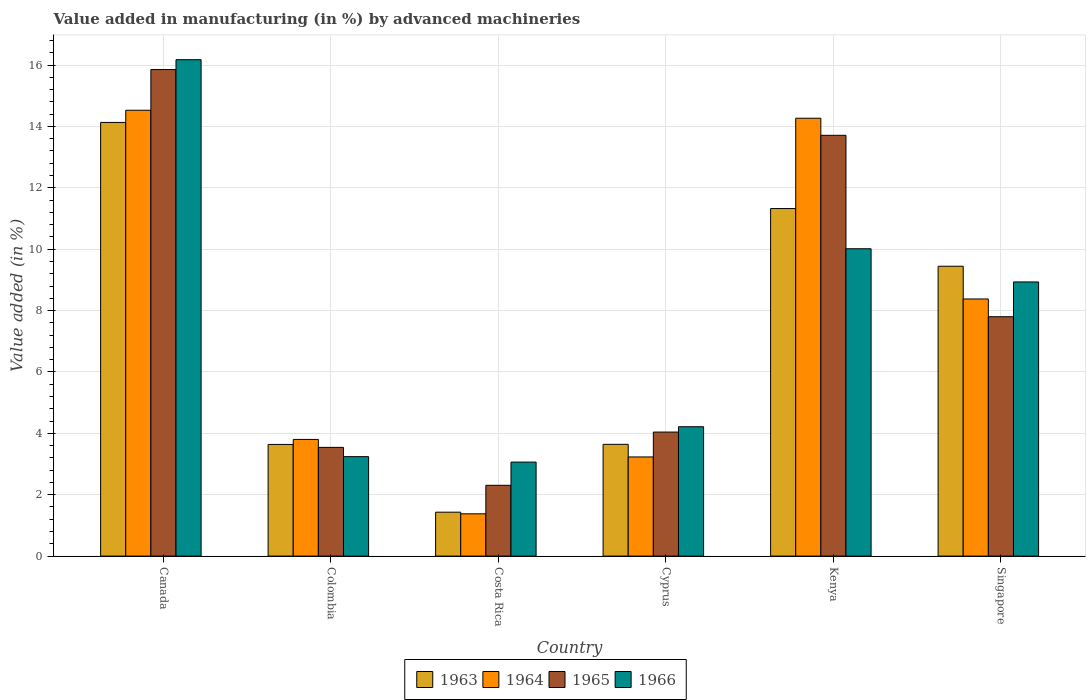What is the label of the 6th group of bars from the left?
Your answer should be very brief. Singapore. What is the percentage of value added in manufacturing by advanced machineries in 1964 in Colombia?
Your response must be concise. 3.8. Across all countries, what is the maximum percentage of value added in manufacturing by advanced machineries in 1964?
Provide a succinct answer. 14.53. Across all countries, what is the minimum percentage of value added in manufacturing by advanced machineries in 1963?
Your answer should be very brief. 1.43. In which country was the percentage of value added in manufacturing by advanced machineries in 1963 maximum?
Your answer should be very brief. Canada. What is the total percentage of value added in manufacturing by advanced machineries in 1966 in the graph?
Provide a succinct answer. 45.64. What is the difference between the percentage of value added in manufacturing by advanced machineries in 1966 in Canada and that in Singapore?
Offer a very short reply. 7.24. What is the difference between the percentage of value added in manufacturing by advanced machineries in 1965 in Canada and the percentage of value added in manufacturing by advanced machineries in 1964 in Colombia?
Provide a short and direct response. 12.05. What is the average percentage of value added in manufacturing by advanced machineries in 1963 per country?
Keep it short and to the point. 7.27. What is the difference between the percentage of value added in manufacturing by advanced machineries of/in 1964 and percentage of value added in manufacturing by advanced machineries of/in 1966 in Colombia?
Provide a succinct answer. 0.56. In how many countries, is the percentage of value added in manufacturing by advanced machineries in 1963 greater than 1.2000000000000002 %?
Give a very brief answer. 6. What is the ratio of the percentage of value added in manufacturing by advanced machineries in 1966 in Colombia to that in Singapore?
Offer a very short reply. 0.36. Is the difference between the percentage of value added in manufacturing by advanced machineries in 1964 in Cyprus and Kenya greater than the difference between the percentage of value added in manufacturing by advanced machineries in 1966 in Cyprus and Kenya?
Your response must be concise. No. What is the difference between the highest and the second highest percentage of value added in manufacturing by advanced machineries in 1964?
Offer a terse response. -6.15. What is the difference between the highest and the lowest percentage of value added in manufacturing by advanced machineries in 1966?
Offer a terse response. 13.11. In how many countries, is the percentage of value added in manufacturing by advanced machineries in 1965 greater than the average percentage of value added in manufacturing by advanced machineries in 1965 taken over all countries?
Make the answer very short. 2. What does the 2nd bar from the left in Canada represents?
Ensure brevity in your answer.  1964. What does the 4th bar from the right in Canada represents?
Offer a terse response. 1963. Is it the case that in every country, the sum of the percentage of value added in manufacturing by advanced machineries in 1963 and percentage of value added in manufacturing by advanced machineries in 1964 is greater than the percentage of value added in manufacturing by advanced machineries in 1966?
Your response must be concise. No. How many bars are there?
Keep it short and to the point. 24. How many countries are there in the graph?
Make the answer very short. 6. What is the difference between two consecutive major ticks on the Y-axis?
Your response must be concise. 2. Are the values on the major ticks of Y-axis written in scientific E-notation?
Your answer should be compact. No. Does the graph contain grids?
Provide a succinct answer. Yes. Where does the legend appear in the graph?
Provide a succinct answer. Bottom center. How many legend labels are there?
Keep it short and to the point. 4. What is the title of the graph?
Ensure brevity in your answer.  Value added in manufacturing (in %) by advanced machineries. What is the label or title of the Y-axis?
Keep it short and to the point. Value added (in %). What is the Value added (in %) in 1963 in Canada?
Your answer should be compact. 14.13. What is the Value added (in %) of 1964 in Canada?
Offer a terse response. 14.53. What is the Value added (in %) of 1965 in Canada?
Offer a very short reply. 15.85. What is the Value added (in %) of 1966 in Canada?
Your answer should be compact. 16.17. What is the Value added (in %) of 1963 in Colombia?
Your response must be concise. 3.64. What is the Value added (in %) in 1964 in Colombia?
Provide a short and direct response. 3.8. What is the Value added (in %) in 1965 in Colombia?
Your answer should be very brief. 3.54. What is the Value added (in %) of 1966 in Colombia?
Your response must be concise. 3.24. What is the Value added (in %) in 1963 in Costa Rica?
Give a very brief answer. 1.43. What is the Value added (in %) in 1964 in Costa Rica?
Give a very brief answer. 1.38. What is the Value added (in %) in 1965 in Costa Rica?
Offer a very short reply. 2.31. What is the Value added (in %) of 1966 in Costa Rica?
Your response must be concise. 3.06. What is the Value added (in %) of 1963 in Cyprus?
Offer a terse response. 3.64. What is the Value added (in %) of 1964 in Cyprus?
Provide a short and direct response. 3.23. What is the Value added (in %) of 1965 in Cyprus?
Offer a terse response. 4.04. What is the Value added (in %) in 1966 in Cyprus?
Provide a short and direct response. 4.22. What is the Value added (in %) of 1963 in Kenya?
Keep it short and to the point. 11.32. What is the Value added (in %) of 1964 in Kenya?
Keep it short and to the point. 14.27. What is the Value added (in %) of 1965 in Kenya?
Offer a very short reply. 13.71. What is the Value added (in %) in 1966 in Kenya?
Provide a succinct answer. 10.01. What is the Value added (in %) of 1963 in Singapore?
Make the answer very short. 9.44. What is the Value added (in %) of 1964 in Singapore?
Ensure brevity in your answer.  8.38. What is the Value added (in %) of 1965 in Singapore?
Provide a succinct answer. 7.8. What is the Value added (in %) in 1966 in Singapore?
Provide a short and direct response. 8.93. Across all countries, what is the maximum Value added (in %) of 1963?
Your response must be concise. 14.13. Across all countries, what is the maximum Value added (in %) of 1964?
Ensure brevity in your answer.  14.53. Across all countries, what is the maximum Value added (in %) in 1965?
Offer a very short reply. 15.85. Across all countries, what is the maximum Value added (in %) of 1966?
Your answer should be compact. 16.17. Across all countries, what is the minimum Value added (in %) in 1963?
Offer a terse response. 1.43. Across all countries, what is the minimum Value added (in %) in 1964?
Your answer should be very brief. 1.38. Across all countries, what is the minimum Value added (in %) in 1965?
Your answer should be very brief. 2.31. Across all countries, what is the minimum Value added (in %) in 1966?
Offer a terse response. 3.06. What is the total Value added (in %) of 1963 in the graph?
Ensure brevity in your answer.  43.61. What is the total Value added (in %) of 1964 in the graph?
Keep it short and to the point. 45.58. What is the total Value added (in %) of 1965 in the graph?
Provide a short and direct response. 47.25. What is the total Value added (in %) in 1966 in the graph?
Your answer should be compact. 45.64. What is the difference between the Value added (in %) of 1963 in Canada and that in Colombia?
Your response must be concise. 10.49. What is the difference between the Value added (in %) in 1964 in Canada and that in Colombia?
Your response must be concise. 10.72. What is the difference between the Value added (in %) in 1965 in Canada and that in Colombia?
Keep it short and to the point. 12.31. What is the difference between the Value added (in %) of 1966 in Canada and that in Colombia?
Provide a short and direct response. 12.93. What is the difference between the Value added (in %) in 1963 in Canada and that in Costa Rica?
Offer a very short reply. 12.7. What is the difference between the Value added (in %) of 1964 in Canada and that in Costa Rica?
Make the answer very short. 13.15. What is the difference between the Value added (in %) in 1965 in Canada and that in Costa Rica?
Ensure brevity in your answer.  13.55. What is the difference between the Value added (in %) of 1966 in Canada and that in Costa Rica?
Your response must be concise. 13.11. What is the difference between the Value added (in %) of 1963 in Canada and that in Cyprus?
Ensure brevity in your answer.  10.49. What is the difference between the Value added (in %) in 1964 in Canada and that in Cyprus?
Offer a very short reply. 11.3. What is the difference between the Value added (in %) in 1965 in Canada and that in Cyprus?
Your response must be concise. 11.81. What is the difference between the Value added (in %) of 1966 in Canada and that in Cyprus?
Offer a very short reply. 11.96. What is the difference between the Value added (in %) of 1963 in Canada and that in Kenya?
Make the answer very short. 2.81. What is the difference between the Value added (in %) of 1964 in Canada and that in Kenya?
Offer a very short reply. 0.26. What is the difference between the Value added (in %) in 1965 in Canada and that in Kenya?
Your response must be concise. 2.14. What is the difference between the Value added (in %) of 1966 in Canada and that in Kenya?
Provide a succinct answer. 6.16. What is the difference between the Value added (in %) of 1963 in Canada and that in Singapore?
Make the answer very short. 4.69. What is the difference between the Value added (in %) of 1964 in Canada and that in Singapore?
Offer a terse response. 6.15. What is the difference between the Value added (in %) in 1965 in Canada and that in Singapore?
Make the answer very short. 8.05. What is the difference between the Value added (in %) of 1966 in Canada and that in Singapore?
Offer a terse response. 7.24. What is the difference between the Value added (in %) of 1963 in Colombia and that in Costa Rica?
Your answer should be compact. 2.21. What is the difference between the Value added (in %) of 1964 in Colombia and that in Costa Rica?
Provide a succinct answer. 2.42. What is the difference between the Value added (in %) in 1965 in Colombia and that in Costa Rica?
Keep it short and to the point. 1.24. What is the difference between the Value added (in %) in 1966 in Colombia and that in Costa Rica?
Make the answer very short. 0.18. What is the difference between the Value added (in %) of 1963 in Colombia and that in Cyprus?
Make the answer very short. -0. What is the difference between the Value added (in %) in 1964 in Colombia and that in Cyprus?
Provide a succinct answer. 0.57. What is the difference between the Value added (in %) of 1965 in Colombia and that in Cyprus?
Offer a terse response. -0.5. What is the difference between the Value added (in %) of 1966 in Colombia and that in Cyprus?
Ensure brevity in your answer.  -0.97. What is the difference between the Value added (in %) in 1963 in Colombia and that in Kenya?
Give a very brief answer. -7.69. What is the difference between the Value added (in %) of 1964 in Colombia and that in Kenya?
Ensure brevity in your answer.  -10.47. What is the difference between the Value added (in %) in 1965 in Colombia and that in Kenya?
Provide a short and direct response. -10.17. What is the difference between the Value added (in %) in 1966 in Colombia and that in Kenya?
Your answer should be very brief. -6.77. What is the difference between the Value added (in %) in 1963 in Colombia and that in Singapore?
Provide a short and direct response. -5.81. What is the difference between the Value added (in %) in 1964 in Colombia and that in Singapore?
Your answer should be very brief. -4.58. What is the difference between the Value added (in %) of 1965 in Colombia and that in Singapore?
Ensure brevity in your answer.  -4.26. What is the difference between the Value added (in %) in 1966 in Colombia and that in Singapore?
Your answer should be compact. -5.69. What is the difference between the Value added (in %) in 1963 in Costa Rica and that in Cyprus?
Your answer should be compact. -2.21. What is the difference between the Value added (in %) in 1964 in Costa Rica and that in Cyprus?
Offer a very short reply. -1.85. What is the difference between the Value added (in %) in 1965 in Costa Rica and that in Cyprus?
Provide a succinct answer. -1.73. What is the difference between the Value added (in %) of 1966 in Costa Rica and that in Cyprus?
Make the answer very short. -1.15. What is the difference between the Value added (in %) in 1963 in Costa Rica and that in Kenya?
Ensure brevity in your answer.  -9.89. What is the difference between the Value added (in %) in 1964 in Costa Rica and that in Kenya?
Your response must be concise. -12.89. What is the difference between the Value added (in %) in 1965 in Costa Rica and that in Kenya?
Your response must be concise. -11.4. What is the difference between the Value added (in %) of 1966 in Costa Rica and that in Kenya?
Offer a very short reply. -6.95. What is the difference between the Value added (in %) of 1963 in Costa Rica and that in Singapore?
Offer a terse response. -8.01. What is the difference between the Value added (in %) of 1964 in Costa Rica and that in Singapore?
Your answer should be compact. -7. What is the difference between the Value added (in %) of 1965 in Costa Rica and that in Singapore?
Your answer should be very brief. -5.49. What is the difference between the Value added (in %) of 1966 in Costa Rica and that in Singapore?
Make the answer very short. -5.87. What is the difference between the Value added (in %) of 1963 in Cyprus and that in Kenya?
Provide a short and direct response. -7.68. What is the difference between the Value added (in %) in 1964 in Cyprus and that in Kenya?
Provide a succinct answer. -11.04. What is the difference between the Value added (in %) of 1965 in Cyprus and that in Kenya?
Provide a short and direct response. -9.67. What is the difference between the Value added (in %) in 1966 in Cyprus and that in Kenya?
Your answer should be very brief. -5.8. What is the difference between the Value added (in %) in 1963 in Cyprus and that in Singapore?
Provide a succinct answer. -5.8. What is the difference between the Value added (in %) in 1964 in Cyprus and that in Singapore?
Offer a very short reply. -5.15. What is the difference between the Value added (in %) of 1965 in Cyprus and that in Singapore?
Make the answer very short. -3.76. What is the difference between the Value added (in %) of 1966 in Cyprus and that in Singapore?
Ensure brevity in your answer.  -4.72. What is the difference between the Value added (in %) of 1963 in Kenya and that in Singapore?
Keep it short and to the point. 1.88. What is the difference between the Value added (in %) in 1964 in Kenya and that in Singapore?
Give a very brief answer. 5.89. What is the difference between the Value added (in %) in 1965 in Kenya and that in Singapore?
Your response must be concise. 5.91. What is the difference between the Value added (in %) in 1966 in Kenya and that in Singapore?
Your answer should be very brief. 1.08. What is the difference between the Value added (in %) in 1963 in Canada and the Value added (in %) in 1964 in Colombia?
Your answer should be very brief. 10.33. What is the difference between the Value added (in %) of 1963 in Canada and the Value added (in %) of 1965 in Colombia?
Ensure brevity in your answer.  10.59. What is the difference between the Value added (in %) in 1963 in Canada and the Value added (in %) in 1966 in Colombia?
Your response must be concise. 10.89. What is the difference between the Value added (in %) of 1964 in Canada and the Value added (in %) of 1965 in Colombia?
Offer a terse response. 10.98. What is the difference between the Value added (in %) in 1964 in Canada and the Value added (in %) in 1966 in Colombia?
Offer a very short reply. 11.29. What is the difference between the Value added (in %) of 1965 in Canada and the Value added (in %) of 1966 in Colombia?
Offer a very short reply. 12.61. What is the difference between the Value added (in %) in 1963 in Canada and the Value added (in %) in 1964 in Costa Rica?
Your answer should be very brief. 12.75. What is the difference between the Value added (in %) in 1963 in Canada and the Value added (in %) in 1965 in Costa Rica?
Keep it short and to the point. 11.82. What is the difference between the Value added (in %) in 1963 in Canada and the Value added (in %) in 1966 in Costa Rica?
Give a very brief answer. 11.07. What is the difference between the Value added (in %) in 1964 in Canada and the Value added (in %) in 1965 in Costa Rica?
Provide a short and direct response. 12.22. What is the difference between the Value added (in %) of 1964 in Canada and the Value added (in %) of 1966 in Costa Rica?
Make the answer very short. 11.46. What is the difference between the Value added (in %) in 1965 in Canada and the Value added (in %) in 1966 in Costa Rica?
Keep it short and to the point. 12.79. What is the difference between the Value added (in %) of 1963 in Canada and the Value added (in %) of 1964 in Cyprus?
Your answer should be very brief. 10.9. What is the difference between the Value added (in %) of 1963 in Canada and the Value added (in %) of 1965 in Cyprus?
Provide a short and direct response. 10.09. What is the difference between the Value added (in %) of 1963 in Canada and the Value added (in %) of 1966 in Cyprus?
Provide a short and direct response. 9.92. What is the difference between the Value added (in %) in 1964 in Canada and the Value added (in %) in 1965 in Cyprus?
Your answer should be very brief. 10.49. What is the difference between the Value added (in %) of 1964 in Canada and the Value added (in %) of 1966 in Cyprus?
Keep it short and to the point. 10.31. What is the difference between the Value added (in %) of 1965 in Canada and the Value added (in %) of 1966 in Cyprus?
Keep it short and to the point. 11.64. What is the difference between the Value added (in %) of 1963 in Canada and the Value added (in %) of 1964 in Kenya?
Provide a succinct answer. -0.14. What is the difference between the Value added (in %) of 1963 in Canada and the Value added (in %) of 1965 in Kenya?
Ensure brevity in your answer.  0.42. What is the difference between the Value added (in %) in 1963 in Canada and the Value added (in %) in 1966 in Kenya?
Offer a very short reply. 4.12. What is the difference between the Value added (in %) of 1964 in Canada and the Value added (in %) of 1965 in Kenya?
Ensure brevity in your answer.  0.82. What is the difference between the Value added (in %) of 1964 in Canada and the Value added (in %) of 1966 in Kenya?
Offer a terse response. 4.51. What is the difference between the Value added (in %) of 1965 in Canada and the Value added (in %) of 1966 in Kenya?
Offer a very short reply. 5.84. What is the difference between the Value added (in %) of 1963 in Canada and the Value added (in %) of 1964 in Singapore?
Make the answer very short. 5.75. What is the difference between the Value added (in %) of 1963 in Canada and the Value added (in %) of 1965 in Singapore?
Make the answer very short. 6.33. What is the difference between the Value added (in %) of 1963 in Canada and the Value added (in %) of 1966 in Singapore?
Provide a succinct answer. 5.2. What is the difference between the Value added (in %) of 1964 in Canada and the Value added (in %) of 1965 in Singapore?
Give a very brief answer. 6.73. What is the difference between the Value added (in %) of 1964 in Canada and the Value added (in %) of 1966 in Singapore?
Your answer should be very brief. 5.59. What is the difference between the Value added (in %) of 1965 in Canada and the Value added (in %) of 1966 in Singapore?
Offer a very short reply. 6.92. What is the difference between the Value added (in %) in 1963 in Colombia and the Value added (in %) in 1964 in Costa Rica?
Your answer should be very brief. 2.26. What is the difference between the Value added (in %) in 1963 in Colombia and the Value added (in %) in 1965 in Costa Rica?
Make the answer very short. 1.33. What is the difference between the Value added (in %) in 1963 in Colombia and the Value added (in %) in 1966 in Costa Rica?
Your response must be concise. 0.57. What is the difference between the Value added (in %) of 1964 in Colombia and the Value added (in %) of 1965 in Costa Rica?
Provide a succinct answer. 1.49. What is the difference between the Value added (in %) of 1964 in Colombia and the Value added (in %) of 1966 in Costa Rica?
Provide a succinct answer. 0.74. What is the difference between the Value added (in %) of 1965 in Colombia and the Value added (in %) of 1966 in Costa Rica?
Ensure brevity in your answer.  0.48. What is the difference between the Value added (in %) of 1963 in Colombia and the Value added (in %) of 1964 in Cyprus?
Your response must be concise. 0.41. What is the difference between the Value added (in %) in 1963 in Colombia and the Value added (in %) in 1965 in Cyprus?
Your answer should be compact. -0.4. What is the difference between the Value added (in %) in 1963 in Colombia and the Value added (in %) in 1966 in Cyprus?
Offer a terse response. -0.58. What is the difference between the Value added (in %) of 1964 in Colombia and the Value added (in %) of 1965 in Cyprus?
Make the answer very short. -0.24. What is the difference between the Value added (in %) of 1964 in Colombia and the Value added (in %) of 1966 in Cyprus?
Offer a very short reply. -0.41. What is the difference between the Value added (in %) of 1965 in Colombia and the Value added (in %) of 1966 in Cyprus?
Ensure brevity in your answer.  -0.67. What is the difference between the Value added (in %) in 1963 in Colombia and the Value added (in %) in 1964 in Kenya?
Your response must be concise. -10.63. What is the difference between the Value added (in %) of 1963 in Colombia and the Value added (in %) of 1965 in Kenya?
Provide a succinct answer. -10.07. What is the difference between the Value added (in %) in 1963 in Colombia and the Value added (in %) in 1966 in Kenya?
Your answer should be compact. -6.38. What is the difference between the Value added (in %) of 1964 in Colombia and the Value added (in %) of 1965 in Kenya?
Your answer should be compact. -9.91. What is the difference between the Value added (in %) in 1964 in Colombia and the Value added (in %) in 1966 in Kenya?
Ensure brevity in your answer.  -6.21. What is the difference between the Value added (in %) in 1965 in Colombia and the Value added (in %) in 1966 in Kenya?
Make the answer very short. -6.47. What is the difference between the Value added (in %) of 1963 in Colombia and the Value added (in %) of 1964 in Singapore?
Give a very brief answer. -4.74. What is the difference between the Value added (in %) in 1963 in Colombia and the Value added (in %) in 1965 in Singapore?
Give a very brief answer. -4.16. What is the difference between the Value added (in %) in 1963 in Colombia and the Value added (in %) in 1966 in Singapore?
Offer a very short reply. -5.29. What is the difference between the Value added (in %) in 1964 in Colombia and the Value added (in %) in 1965 in Singapore?
Provide a succinct answer. -4. What is the difference between the Value added (in %) of 1964 in Colombia and the Value added (in %) of 1966 in Singapore?
Provide a succinct answer. -5.13. What is the difference between the Value added (in %) in 1965 in Colombia and the Value added (in %) in 1966 in Singapore?
Your response must be concise. -5.39. What is the difference between the Value added (in %) of 1963 in Costa Rica and the Value added (in %) of 1964 in Cyprus?
Give a very brief answer. -1.8. What is the difference between the Value added (in %) in 1963 in Costa Rica and the Value added (in %) in 1965 in Cyprus?
Keep it short and to the point. -2.61. What is the difference between the Value added (in %) in 1963 in Costa Rica and the Value added (in %) in 1966 in Cyprus?
Your response must be concise. -2.78. What is the difference between the Value added (in %) of 1964 in Costa Rica and the Value added (in %) of 1965 in Cyprus?
Provide a short and direct response. -2.66. What is the difference between the Value added (in %) of 1964 in Costa Rica and the Value added (in %) of 1966 in Cyprus?
Offer a very short reply. -2.84. What is the difference between the Value added (in %) in 1965 in Costa Rica and the Value added (in %) in 1966 in Cyprus?
Make the answer very short. -1.91. What is the difference between the Value added (in %) of 1963 in Costa Rica and the Value added (in %) of 1964 in Kenya?
Your answer should be very brief. -12.84. What is the difference between the Value added (in %) in 1963 in Costa Rica and the Value added (in %) in 1965 in Kenya?
Your answer should be very brief. -12.28. What is the difference between the Value added (in %) in 1963 in Costa Rica and the Value added (in %) in 1966 in Kenya?
Provide a short and direct response. -8.58. What is the difference between the Value added (in %) of 1964 in Costa Rica and the Value added (in %) of 1965 in Kenya?
Offer a terse response. -12.33. What is the difference between the Value added (in %) in 1964 in Costa Rica and the Value added (in %) in 1966 in Kenya?
Offer a very short reply. -8.64. What is the difference between the Value added (in %) in 1965 in Costa Rica and the Value added (in %) in 1966 in Kenya?
Ensure brevity in your answer.  -7.71. What is the difference between the Value added (in %) of 1963 in Costa Rica and the Value added (in %) of 1964 in Singapore?
Make the answer very short. -6.95. What is the difference between the Value added (in %) in 1963 in Costa Rica and the Value added (in %) in 1965 in Singapore?
Give a very brief answer. -6.37. What is the difference between the Value added (in %) in 1963 in Costa Rica and the Value added (in %) in 1966 in Singapore?
Your response must be concise. -7.5. What is the difference between the Value added (in %) of 1964 in Costa Rica and the Value added (in %) of 1965 in Singapore?
Give a very brief answer. -6.42. What is the difference between the Value added (in %) in 1964 in Costa Rica and the Value added (in %) in 1966 in Singapore?
Keep it short and to the point. -7.55. What is the difference between the Value added (in %) in 1965 in Costa Rica and the Value added (in %) in 1966 in Singapore?
Keep it short and to the point. -6.63. What is the difference between the Value added (in %) of 1963 in Cyprus and the Value added (in %) of 1964 in Kenya?
Make the answer very short. -10.63. What is the difference between the Value added (in %) of 1963 in Cyprus and the Value added (in %) of 1965 in Kenya?
Give a very brief answer. -10.07. What is the difference between the Value added (in %) of 1963 in Cyprus and the Value added (in %) of 1966 in Kenya?
Offer a terse response. -6.37. What is the difference between the Value added (in %) of 1964 in Cyprus and the Value added (in %) of 1965 in Kenya?
Offer a very short reply. -10.48. What is the difference between the Value added (in %) in 1964 in Cyprus and the Value added (in %) in 1966 in Kenya?
Your answer should be compact. -6.78. What is the difference between the Value added (in %) of 1965 in Cyprus and the Value added (in %) of 1966 in Kenya?
Ensure brevity in your answer.  -5.97. What is the difference between the Value added (in %) in 1963 in Cyprus and the Value added (in %) in 1964 in Singapore?
Your answer should be very brief. -4.74. What is the difference between the Value added (in %) in 1963 in Cyprus and the Value added (in %) in 1965 in Singapore?
Give a very brief answer. -4.16. What is the difference between the Value added (in %) in 1963 in Cyprus and the Value added (in %) in 1966 in Singapore?
Ensure brevity in your answer.  -5.29. What is the difference between the Value added (in %) in 1964 in Cyprus and the Value added (in %) in 1965 in Singapore?
Your response must be concise. -4.57. What is the difference between the Value added (in %) of 1964 in Cyprus and the Value added (in %) of 1966 in Singapore?
Your answer should be compact. -5.7. What is the difference between the Value added (in %) of 1965 in Cyprus and the Value added (in %) of 1966 in Singapore?
Ensure brevity in your answer.  -4.89. What is the difference between the Value added (in %) in 1963 in Kenya and the Value added (in %) in 1964 in Singapore?
Provide a succinct answer. 2.95. What is the difference between the Value added (in %) of 1963 in Kenya and the Value added (in %) of 1965 in Singapore?
Make the answer very short. 3.52. What is the difference between the Value added (in %) of 1963 in Kenya and the Value added (in %) of 1966 in Singapore?
Provide a short and direct response. 2.39. What is the difference between the Value added (in %) in 1964 in Kenya and the Value added (in %) in 1965 in Singapore?
Ensure brevity in your answer.  6.47. What is the difference between the Value added (in %) of 1964 in Kenya and the Value added (in %) of 1966 in Singapore?
Make the answer very short. 5.33. What is the difference between the Value added (in %) of 1965 in Kenya and the Value added (in %) of 1966 in Singapore?
Make the answer very short. 4.78. What is the average Value added (in %) in 1963 per country?
Provide a succinct answer. 7.27. What is the average Value added (in %) in 1964 per country?
Offer a terse response. 7.6. What is the average Value added (in %) in 1965 per country?
Keep it short and to the point. 7.88. What is the average Value added (in %) in 1966 per country?
Offer a very short reply. 7.61. What is the difference between the Value added (in %) of 1963 and Value added (in %) of 1964 in Canada?
Give a very brief answer. -0.4. What is the difference between the Value added (in %) of 1963 and Value added (in %) of 1965 in Canada?
Your answer should be compact. -1.72. What is the difference between the Value added (in %) of 1963 and Value added (in %) of 1966 in Canada?
Your answer should be very brief. -2.04. What is the difference between the Value added (in %) of 1964 and Value added (in %) of 1965 in Canada?
Your answer should be compact. -1.33. What is the difference between the Value added (in %) of 1964 and Value added (in %) of 1966 in Canada?
Your response must be concise. -1.65. What is the difference between the Value added (in %) in 1965 and Value added (in %) in 1966 in Canada?
Give a very brief answer. -0.32. What is the difference between the Value added (in %) of 1963 and Value added (in %) of 1964 in Colombia?
Ensure brevity in your answer.  -0.16. What is the difference between the Value added (in %) of 1963 and Value added (in %) of 1965 in Colombia?
Offer a terse response. 0.1. What is the difference between the Value added (in %) in 1963 and Value added (in %) in 1966 in Colombia?
Make the answer very short. 0.4. What is the difference between the Value added (in %) of 1964 and Value added (in %) of 1965 in Colombia?
Your response must be concise. 0.26. What is the difference between the Value added (in %) of 1964 and Value added (in %) of 1966 in Colombia?
Make the answer very short. 0.56. What is the difference between the Value added (in %) of 1965 and Value added (in %) of 1966 in Colombia?
Offer a very short reply. 0.3. What is the difference between the Value added (in %) in 1963 and Value added (in %) in 1964 in Costa Rica?
Offer a very short reply. 0.05. What is the difference between the Value added (in %) in 1963 and Value added (in %) in 1965 in Costa Rica?
Your answer should be compact. -0.88. What is the difference between the Value added (in %) in 1963 and Value added (in %) in 1966 in Costa Rica?
Give a very brief answer. -1.63. What is the difference between the Value added (in %) in 1964 and Value added (in %) in 1965 in Costa Rica?
Make the answer very short. -0.93. What is the difference between the Value added (in %) of 1964 and Value added (in %) of 1966 in Costa Rica?
Make the answer very short. -1.69. What is the difference between the Value added (in %) in 1965 and Value added (in %) in 1966 in Costa Rica?
Your response must be concise. -0.76. What is the difference between the Value added (in %) of 1963 and Value added (in %) of 1964 in Cyprus?
Offer a very short reply. 0.41. What is the difference between the Value added (in %) in 1963 and Value added (in %) in 1965 in Cyprus?
Give a very brief answer. -0.4. What is the difference between the Value added (in %) in 1963 and Value added (in %) in 1966 in Cyprus?
Your response must be concise. -0.57. What is the difference between the Value added (in %) in 1964 and Value added (in %) in 1965 in Cyprus?
Keep it short and to the point. -0.81. What is the difference between the Value added (in %) of 1964 and Value added (in %) of 1966 in Cyprus?
Offer a terse response. -0.98. What is the difference between the Value added (in %) in 1965 and Value added (in %) in 1966 in Cyprus?
Give a very brief answer. -0.17. What is the difference between the Value added (in %) in 1963 and Value added (in %) in 1964 in Kenya?
Your response must be concise. -2.94. What is the difference between the Value added (in %) in 1963 and Value added (in %) in 1965 in Kenya?
Your response must be concise. -2.39. What is the difference between the Value added (in %) in 1963 and Value added (in %) in 1966 in Kenya?
Make the answer very short. 1.31. What is the difference between the Value added (in %) of 1964 and Value added (in %) of 1965 in Kenya?
Make the answer very short. 0.56. What is the difference between the Value added (in %) in 1964 and Value added (in %) in 1966 in Kenya?
Keep it short and to the point. 4.25. What is the difference between the Value added (in %) of 1965 and Value added (in %) of 1966 in Kenya?
Offer a very short reply. 3.7. What is the difference between the Value added (in %) in 1963 and Value added (in %) in 1964 in Singapore?
Make the answer very short. 1.07. What is the difference between the Value added (in %) in 1963 and Value added (in %) in 1965 in Singapore?
Provide a succinct answer. 1.64. What is the difference between the Value added (in %) of 1963 and Value added (in %) of 1966 in Singapore?
Provide a succinct answer. 0.51. What is the difference between the Value added (in %) in 1964 and Value added (in %) in 1965 in Singapore?
Make the answer very short. 0.58. What is the difference between the Value added (in %) in 1964 and Value added (in %) in 1966 in Singapore?
Provide a short and direct response. -0.55. What is the difference between the Value added (in %) of 1965 and Value added (in %) of 1966 in Singapore?
Give a very brief answer. -1.13. What is the ratio of the Value added (in %) in 1963 in Canada to that in Colombia?
Give a very brief answer. 3.88. What is the ratio of the Value added (in %) of 1964 in Canada to that in Colombia?
Offer a very short reply. 3.82. What is the ratio of the Value added (in %) of 1965 in Canada to that in Colombia?
Your answer should be compact. 4.48. What is the ratio of the Value added (in %) of 1966 in Canada to that in Colombia?
Offer a very short reply. 4.99. What is the ratio of the Value added (in %) of 1963 in Canada to that in Costa Rica?
Provide a short and direct response. 9.87. What is the ratio of the Value added (in %) in 1964 in Canada to that in Costa Rica?
Your answer should be very brief. 10.54. What is the ratio of the Value added (in %) in 1965 in Canada to that in Costa Rica?
Keep it short and to the point. 6.87. What is the ratio of the Value added (in %) in 1966 in Canada to that in Costa Rica?
Offer a terse response. 5.28. What is the ratio of the Value added (in %) in 1963 in Canada to that in Cyprus?
Offer a terse response. 3.88. What is the ratio of the Value added (in %) of 1964 in Canada to that in Cyprus?
Ensure brevity in your answer.  4.5. What is the ratio of the Value added (in %) of 1965 in Canada to that in Cyprus?
Offer a terse response. 3.92. What is the ratio of the Value added (in %) in 1966 in Canada to that in Cyprus?
Keep it short and to the point. 3.84. What is the ratio of the Value added (in %) of 1963 in Canada to that in Kenya?
Your answer should be very brief. 1.25. What is the ratio of the Value added (in %) of 1964 in Canada to that in Kenya?
Offer a terse response. 1.02. What is the ratio of the Value added (in %) of 1965 in Canada to that in Kenya?
Your answer should be compact. 1.16. What is the ratio of the Value added (in %) in 1966 in Canada to that in Kenya?
Make the answer very short. 1.62. What is the ratio of the Value added (in %) of 1963 in Canada to that in Singapore?
Provide a short and direct response. 1.5. What is the ratio of the Value added (in %) of 1964 in Canada to that in Singapore?
Give a very brief answer. 1.73. What is the ratio of the Value added (in %) in 1965 in Canada to that in Singapore?
Keep it short and to the point. 2.03. What is the ratio of the Value added (in %) of 1966 in Canada to that in Singapore?
Give a very brief answer. 1.81. What is the ratio of the Value added (in %) of 1963 in Colombia to that in Costa Rica?
Provide a succinct answer. 2.54. What is the ratio of the Value added (in %) of 1964 in Colombia to that in Costa Rica?
Your answer should be very brief. 2.76. What is the ratio of the Value added (in %) of 1965 in Colombia to that in Costa Rica?
Give a very brief answer. 1.54. What is the ratio of the Value added (in %) in 1966 in Colombia to that in Costa Rica?
Your answer should be compact. 1.06. What is the ratio of the Value added (in %) of 1963 in Colombia to that in Cyprus?
Ensure brevity in your answer.  1. What is the ratio of the Value added (in %) in 1964 in Colombia to that in Cyprus?
Provide a succinct answer. 1.18. What is the ratio of the Value added (in %) in 1965 in Colombia to that in Cyprus?
Offer a very short reply. 0.88. What is the ratio of the Value added (in %) of 1966 in Colombia to that in Cyprus?
Ensure brevity in your answer.  0.77. What is the ratio of the Value added (in %) in 1963 in Colombia to that in Kenya?
Make the answer very short. 0.32. What is the ratio of the Value added (in %) in 1964 in Colombia to that in Kenya?
Your response must be concise. 0.27. What is the ratio of the Value added (in %) in 1965 in Colombia to that in Kenya?
Provide a succinct answer. 0.26. What is the ratio of the Value added (in %) in 1966 in Colombia to that in Kenya?
Keep it short and to the point. 0.32. What is the ratio of the Value added (in %) of 1963 in Colombia to that in Singapore?
Your response must be concise. 0.39. What is the ratio of the Value added (in %) in 1964 in Colombia to that in Singapore?
Provide a succinct answer. 0.45. What is the ratio of the Value added (in %) in 1965 in Colombia to that in Singapore?
Offer a very short reply. 0.45. What is the ratio of the Value added (in %) in 1966 in Colombia to that in Singapore?
Make the answer very short. 0.36. What is the ratio of the Value added (in %) of 1963 in Costa Rica to that in Cyprus?
Offer a very short reply. 0.39. What is the ratio of the Value added (in %) in 1964 in Costa Rica to that in Cyprus?
Make the answer very short. 0.43. What is the ratio of the Value added (in %) of 1965 in Costa Rica to that in Cyprus?
Make the answer very short. 0.57. What is the ratio of the Value added (in %) in 1966 in Costa Rica to that in Cyprus?
Provide a succinct answer. 0.73. What is the ratio of the Value added (in %) in 1963 in Costa Rica to that in Kenya?
Provide a succinct answer. 0.13. What is the ratio of the Value added (in %) of 1964 in Costa Rica to that in Kenya?
Offer a very short reply. 0.1. What is the ratio of the Value added (in %) in 1965 in Costa Rica to that in Kenya?
Your answer should be compact. 0.17. What is the ratio of the Value added (in %) in 1966 in Costa Rica to that in Kenya?
Give a very brief answer. 0.31. What is the ratio of the Value added (in %) in 1963 in Costa Rica to that in Singapore?
Your answer should be compact. 0.15. What is the ratio of the Value added (in %) in 1964 in Costa Rica to that in Singapore?
Provide a succinct answer. 0.16. What is the ratio of the Value added (in %) in 1965 in Costa Rica to that in Singapore?
Make the answer very short. 0.3. What is the ratio of the Value added (in %) in 1966 in Costa Rica to that in Singapore?
Ensure brevity in your answer.  0.34. What is the ratio of the Value added (in %) of 1963 in Cyprus to that in Kenya?
Your answer should be very brief. 0.32. What is the ratio of the Value added (in %) of 1964 in Cyprus to that in Kenya?
Offer a very short reply. 0.23. What is the ratio of the Value added (in %) of 1965 in Cyprus to that in Kenya?
Your answer should be compact. 0.29. What is the ratio of the Value added (in %) of 1966 in Cyprus to that in Kenya?
Keep it short and to the point. 0.42. What is the ratio of the Value added (in %) of 1963 in Cyprus to that in Singapore?
Provide a short and direct response. 0.39. What is the ratio of the Value added (in %) of 1964 in Cyprus to that in Singapore?
Make the answer very short. 0.39. What is the ratio of the Value added (in %) in 1965 in Cyprus to that in Singapore?
Make the answer very short. 0.52. What is the ratio of the Value added (in %) of 1966 in Cyprus to that in Singapore?
Provide a short and direct response. 0.47. What is the ratio of the Value added (in %) in 1963 in Kenya to that in Singapore?
Give a very brief answer. 1.2. What is the ratio of the Value added (in %) of 1964 in Kenya to that in Singapore?
Keep it short and to the point. 1.7. What is the ratio of the Value added (in %) of 1965 in Kenya to that in Singapore?
Keep it short and to the point. 1.76. What is the ratio of the Value added (in %) of 1966 in Kenya to that in Singapore?
Your answer should be very brief. 1.12. What is the difference between the highest and the second highest Value added (in %) in 1963?
Your response must be concise. 2.81. What is the difference between the highest and the second highest Value added (in %) in 1964?
Offer a very short reply. 0.26. What is the difference between the highest and the second highest Value added (in %) of 1965?
Offer a terse response. 2.14. What is the difference between the highest and the second highest Value added (in %) of 1966?
Your response must be concise. 6.16. What is the difference between the highest and the lowest Value added (in %) in 1963?
Give a very brief answer. 12.7. What is the difference between the highest and the lowest Value added (in %) of 1964?
Provide a succinct answer. 13.15. What is the difference between the highest and the lowest Value added (in %) in 1965?
Offer a very short reply. 13.55. What is the difference between the highest and the lowest Value added (in %) of 1966?
Offer a terse response. 13.11. 